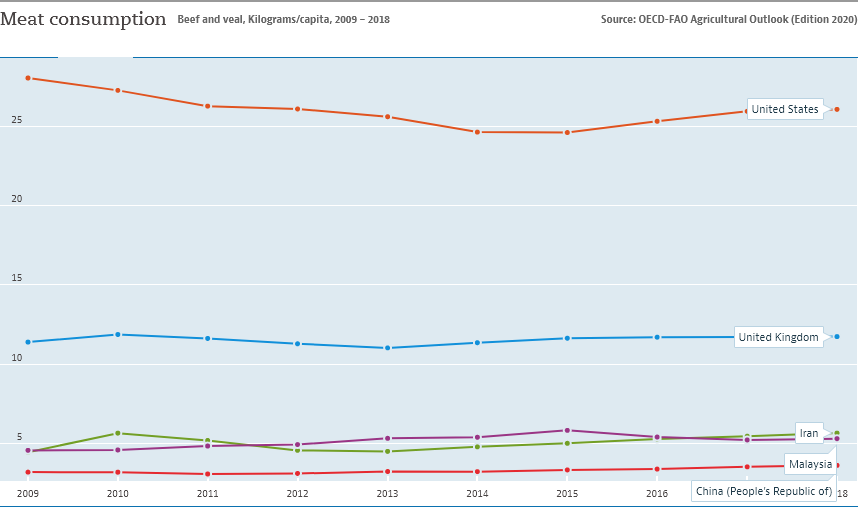Draw attention to some important aspects in this diagram. The orange color bar is located at the top of the graph. There are three bars between the United States and China. 